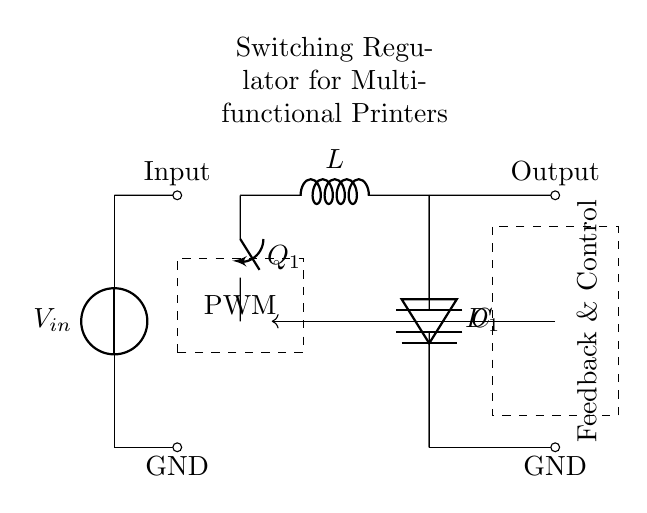What is the input source voltage in the circuit? The input source voltage is labeled as "$V_{in}$" at the top left corner, indicating it is the voltage supplied to the circuit.
Answer: V_{in} What type of switch is used in the circuit? The switch used in the circuit is labeled as "$Q_1$," which typically refers to a transistor or similar electronic switch in a switching regulator configuration.
Answer: Q_1 What is the component connected to the output labeled as? The component connected to the output is labeled as "$C$," indicating it is a capacitor, which is typically used to smooth the output voltage in a regulator circuit.
Answer: C How does the feedback and control section interact with the PWM controller? The feedback and control section is represented by a dashed rectangle, which receives signals from the output to adjust the PWM controller's duty cycle, ultimately managing the output voltage efficiently.
Answer: Receives signals What is the purpose of the inductor in this circuit? The inductor, labeled as "$L$," stores energy when the switch is closed and releases it when the switch is opened, helping maintain a steady output voltage during the switching process.
Answer: Energy storage What type of signal does the PWM controller generate? The PWM (Pulse Width Modulation) controller generates a controlled switching signal, adjusting the duty cycle to regulate the output voltage based on feedback from the output section.
Answer: Switching signal What is the role of the diode in this circuit? The diode, labeled as "$D_1$," allows current to flow from the inductor to the output capacitor while preventing reverse current flow when the switch is turned off, ensuring proper energy transfer.
Answer: Prevents reverse current 